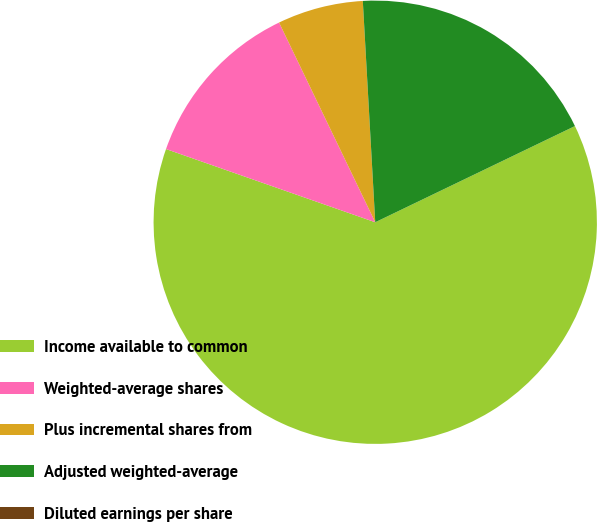Convert chart. <chart><loc_0><loc_0><loc_500><loc_500><pie_chart><fcel>Income available to common<fcel>Weighted-average shares<fcel>Plus incremental shares from<fcel>Adjusted weighted-average<fcel>Diluted earnings per share<nl><fcel>62.5%<fcel>12.5%<fcel>6.25%<fcel>18.75%<fcel>0.0%<nl></chart> 